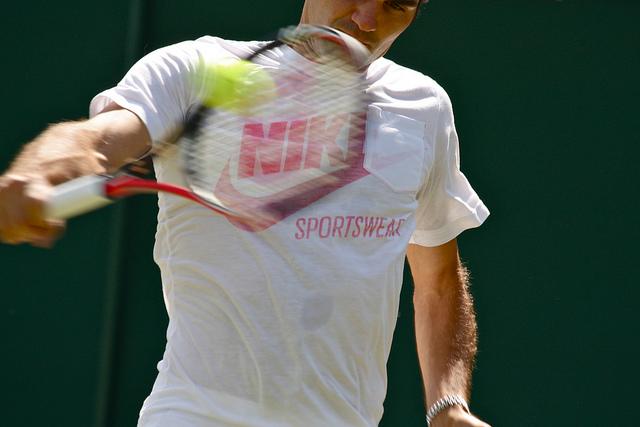Where is the NIKE logo?
Short answer required. Shirt. What famous athlete is playing tennis in the photo?
Give a very brief answer. Nadal. What sport is on the photo?
Be succinct. Tennis. 